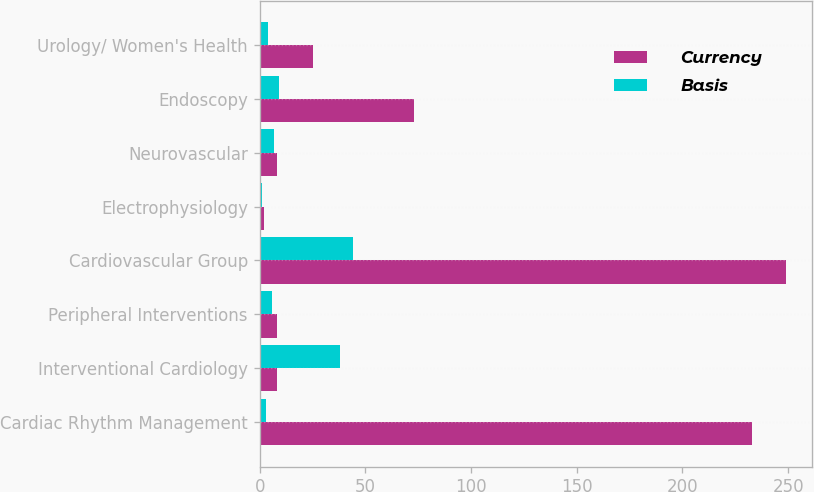Convert chart. <chart><loc_0><loc_0><loc_500><loc_500><stacked_bar_chart><ecel><fcel>Cardiac Rhythm Management<fcel>Interventional Cardiology<fcel>Peripheral Interventions<fcel>Cardiovascular Group<fcel>Electrophysiology<fcel>Neurovascular<fcel>Endoscopy<fcel>Urology/ Women's Health<nl><fcel>Currency<fcel>233<fcel>8<fcel>8<fcel>249<fcel>2<fcel>8<fcel>73<fcel>25<nl><fcel>Basis<fcel>3<fcel>38<fcel>6<fcel>44<fcel>1<fcel>7<fcel>9<fcel>4<nl></chart> 